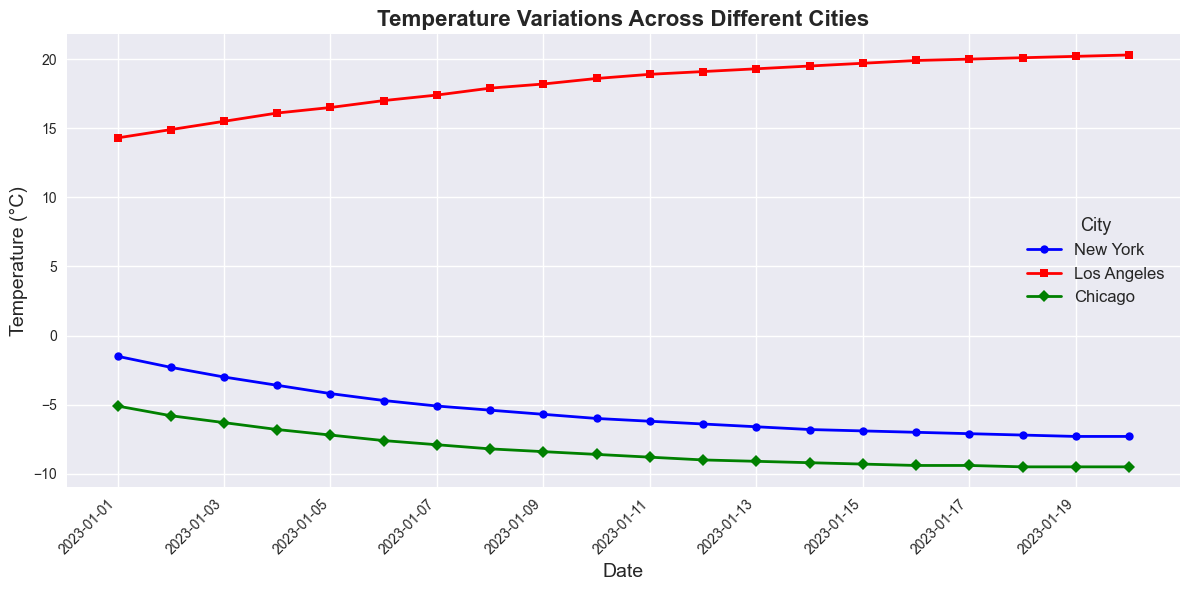What temperature pattern do you observe in New York over the dates shown? To answer this, observe the plot of New York's temperature trend. The line for New York, represented in blue with circle markers, shows a decreasing pattern in temperature over the dates provided.
Answer: The temperature in New York decreases over time Which city has the highest temperature on January 10, 2023? Look at the data points for each city on the date January 10, 2023. In the plot, Los Angeles is represented by a red line with square markers. On January 10, Los Angeles shows the highest temperature compared to New York and Chicago.
Answer: Los Angeles How does Chicago's temperature on January 5, 2023, compare to that on January 10, 2023? Compare the temperature data points for Chicago on January 5 and January 10. Chicago is represented by a green line with diamond markers. On January 5, the temperature is -7.2°C, and on January 10, it is -8.6°C, showing a decrease.
Answer: The temperature in Chicago decreased What is the average temperature for Los Angeles from January 1 to January 5, 2023? Find the temperatures for Los Angeles on the given dates: 14.3°C, 14.9°C, 15.5°C, 16.1°C, and 16.5°C. Calculate the average: (14.3 + 14.9 + 15.5 + 16.1 + 16.5) / 5 = 15.46°C.
Answer: 15.46°C Which city shows the most temperature variation over the full period? Observe the amplitude of the temperature variations for each city. New York and Chicago show significant variations, while Los Angeles shows more stable temperatures. Comparing the amplitudes visually, New York and Chicago have larger variations, but to pinpoint the largest, check the difference between the highest and lowest temperatures in the plot.
Answer: Chicago What is the range of temperatures in New York between January 1 and January 20, 2023? Identify the highest and lowest temperature values for New York over the period. The highest temperature is -1.5°C (January 1), and the lowest is -7.3°C (January 20). The range is calculated as -1.5 - (-7.3) = 5.8°C.
Answer: 5.8°C On January 15, 2023, which city had the closest temperature to 0°C? Look at the temperatures for each city on January 15. New York, Los Angeles, and Chicago have -6.9°C, 19.7°C, and -9.3°C, respectively. The temperatures are all far from 0°C, but among them, New York's temperature of -6.9°C is the closest.
Answer: New York By how much did the temperature in Los Angeles increase from January 1 to January 20, 2023? Note the temperature in Los Angeles on January 1 (14.3°C) and on January 20 (20.3°C). Subtract the initial temperature from the final temperature: 20.3 - 14.3 = 6°C.
Answer: 6°C Is there any day when all three cities had temperatures below 0°C? Examine the data points for all three cities over the period. Los Angeles consistently stays above 0°C. Therefore, there is no day when all three cities had temperatures below 0°C.
Answer: No How does the temperature trend in Los Angeles compare to that in New York on average? Observe the general trend lines for Los Angeles (red, square markers) and New York (blue, circle markers). Los Angeles shows a consistent increase in temperature, while New York shows a decreasing trend over time.
Answer: Los Angeles increases while New York decreases 